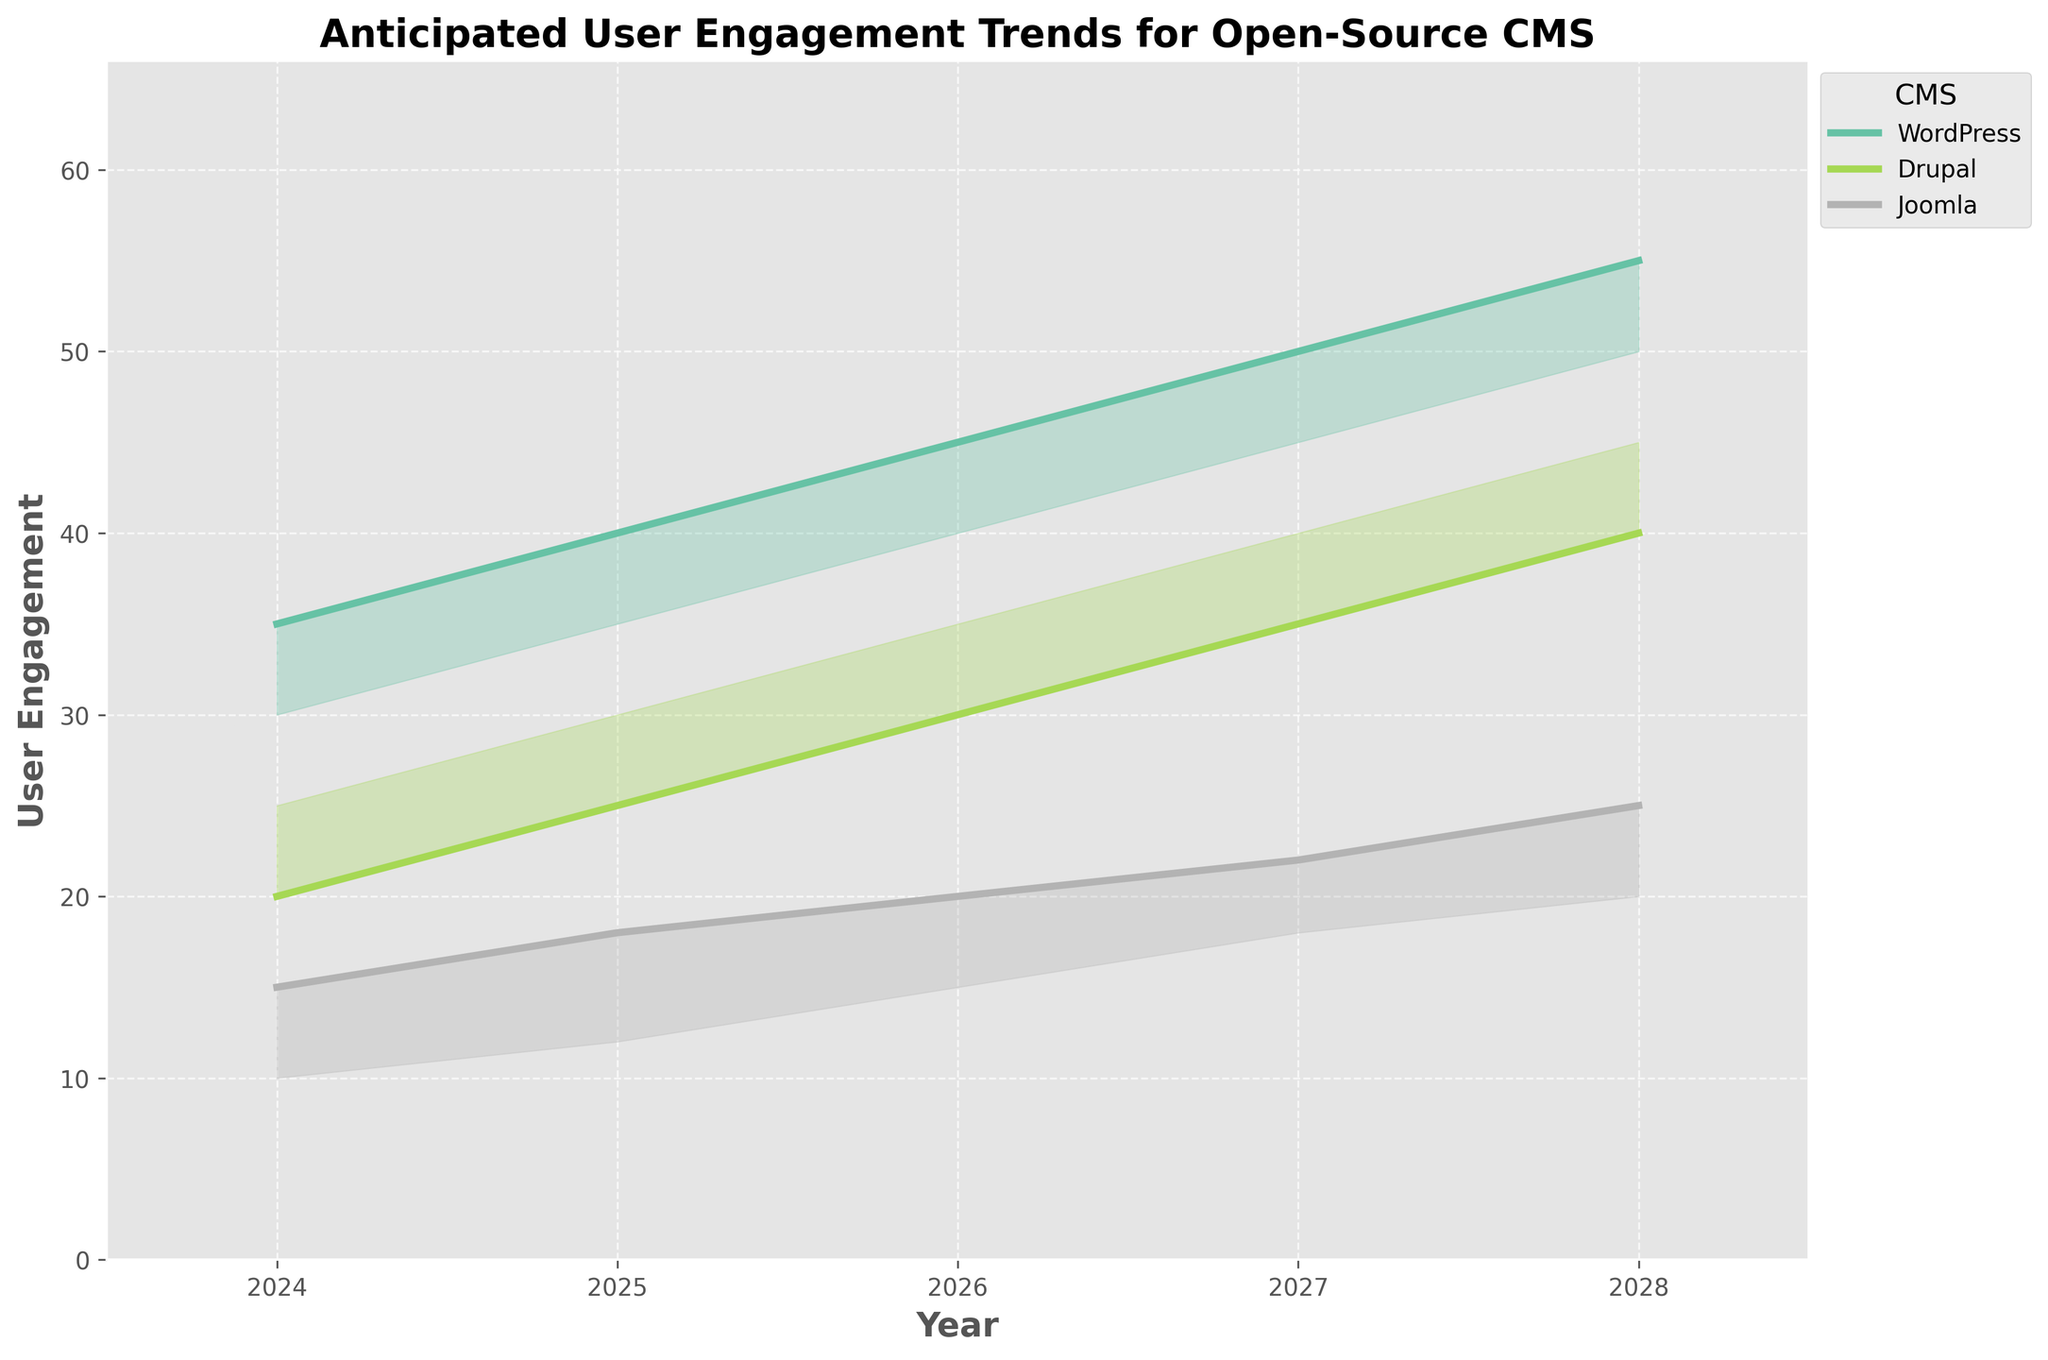What's the title of the figure? The title of the figure is usually placed at the top center of the chart. In this plot, we can see the title displayed as "Anticipated User Engagement Trends for Open-Source CMS"
Answer: Anticipated User Engagement Trends for Open-Source CMS Which CMS has the highest median user engagement in 2024? To find the highest median user engagement, look at the lines representing the median values for each CMS in 2024. The lines are color-coded and labelled.
Answer: WordPress How does the user engagement trend for Drupal in the Healthcare industry change from 2024 to 2028? Follow the line for Drupal within the Healthcare industry, and note the change in user engagement from 2024 to 2028. The user engagement increases each year.
Answer: It increases What is the range of user engagement values for Joomla in the Government sector in 2026? Look at the shaded area for Joomla in the Government sector and identify the lower and upper bounds of the shaded region in the year 2026.
Answer: 20 to 35 In which industry does WordPress have the highest anticipated user engagement in 2028? Compare the median lines for WordPress across different industries in the year 2028. Check which line is the highest.
Answer: E-commerce Which CMS shows a greater increase in anticipated user engagement in the Education sector from 2024 to 2025, Drupal or Joomla? Calculate the difference in user engagement for both Drupal and Joomla from 2024 to 2025 in the Education sector and compare.
Answer: Drupal Between WordPress and Drupal, which CMS has a wider range of user engagement values in the Non-profit industry in 2027? Compare the width of the shaded areas for WordPress and Drupal in 2027 in the Non-profit industry. The wider the shaded area, the greater the range.
Answer: Drupal What is the median anticipated user engagement value for WordPress in the Government sector in 2026? Follow the line for the median values for WordPress in the Government sector in the year 2026.
Answer: 35 